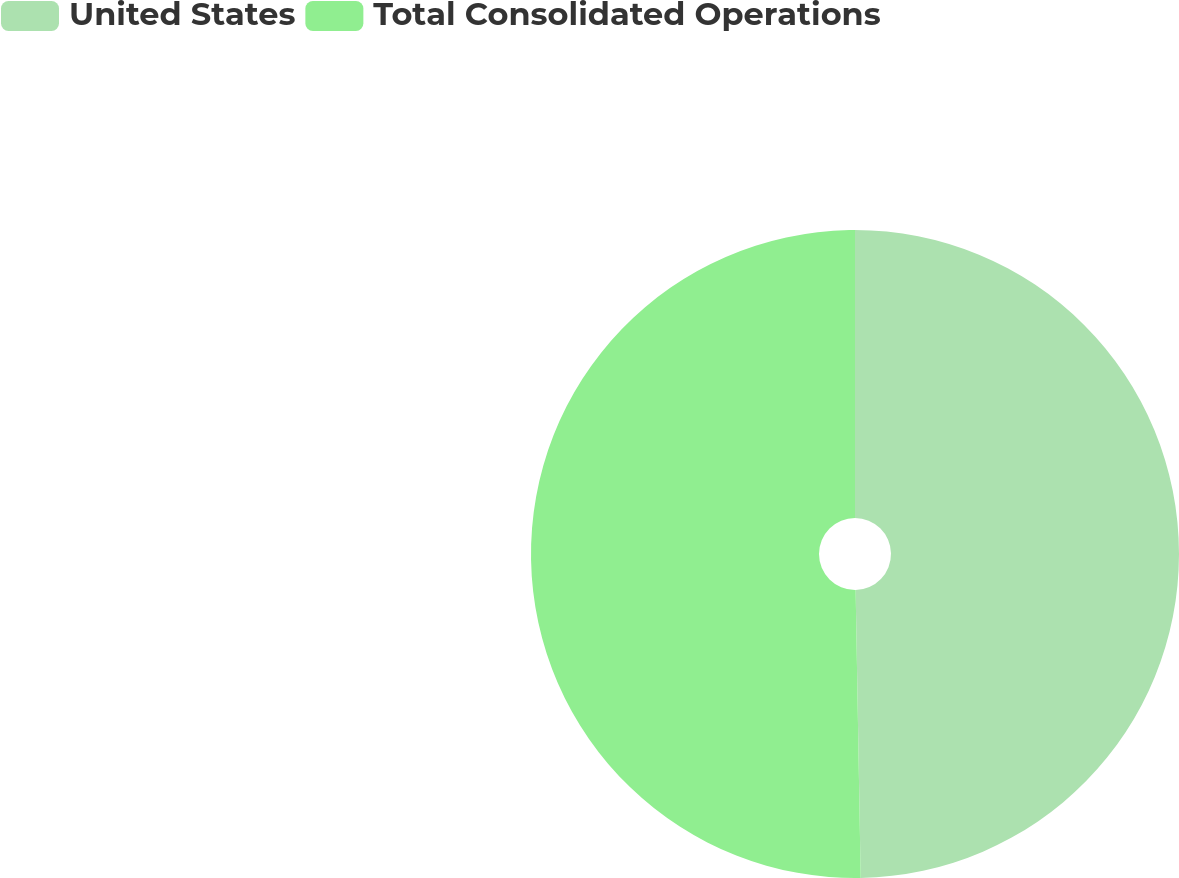Convert chart. <chart><loc_0><loc_0><loc_500><loc_500><pie_chart><fcel>United States<fcel>Total Consolidated Operations<nl><fcel>49.72%<fcel>50.28%<nl></chart> 